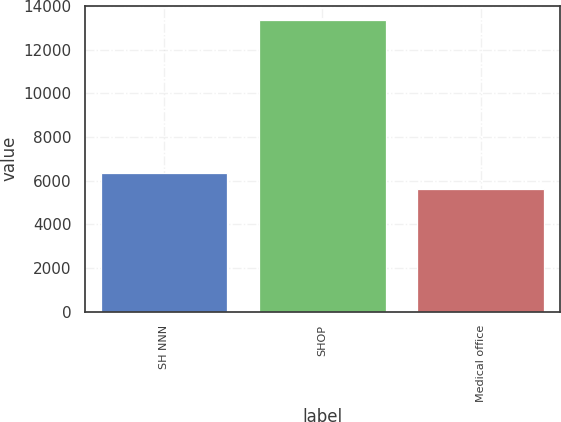<chart> <loc_0><loc_0><loc_500><loc_500><bar_chart><fcel>SH NNN<fcel>SHOP<fcel>Medical office<nl><fcel>6371.5<fcel>13351<fcel>5596<nl></chart> 